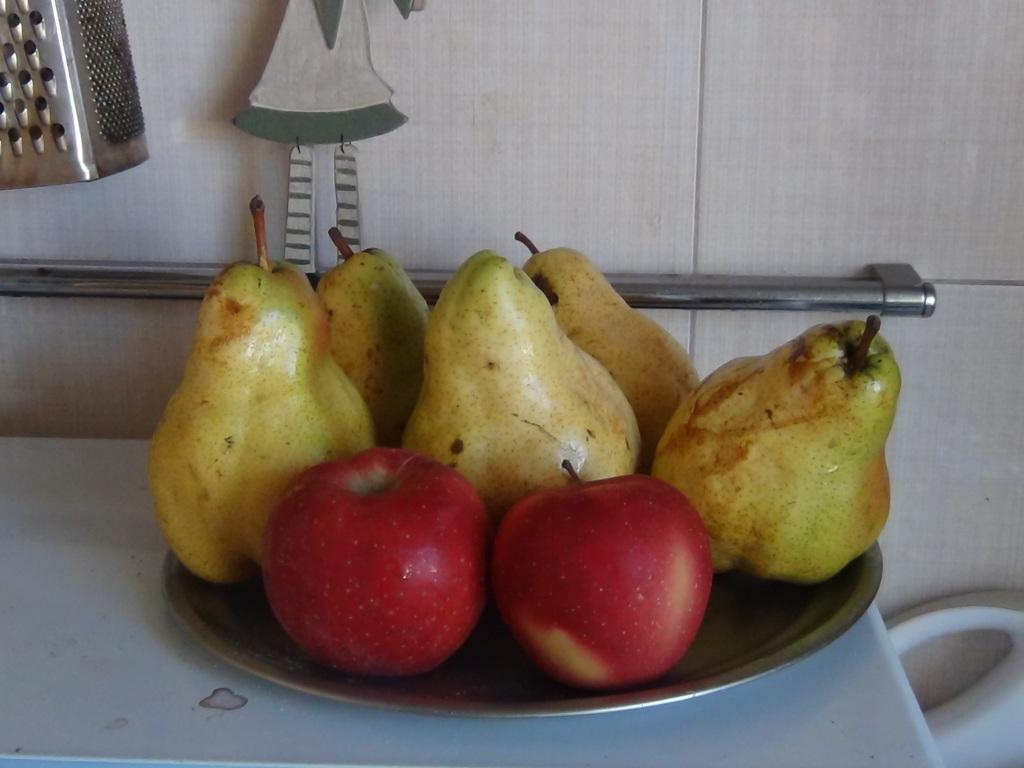What is on the plate that is visible in the image? There are fruits on a plate in the image. Where is the plate located in the image? The plate is placed on a table in the image. What can be seen on the wall in the image? There are objects on the wall in the image. How many pickles are on the table in the image? There is no mention of pickles in the image; the plate contains fruits. 